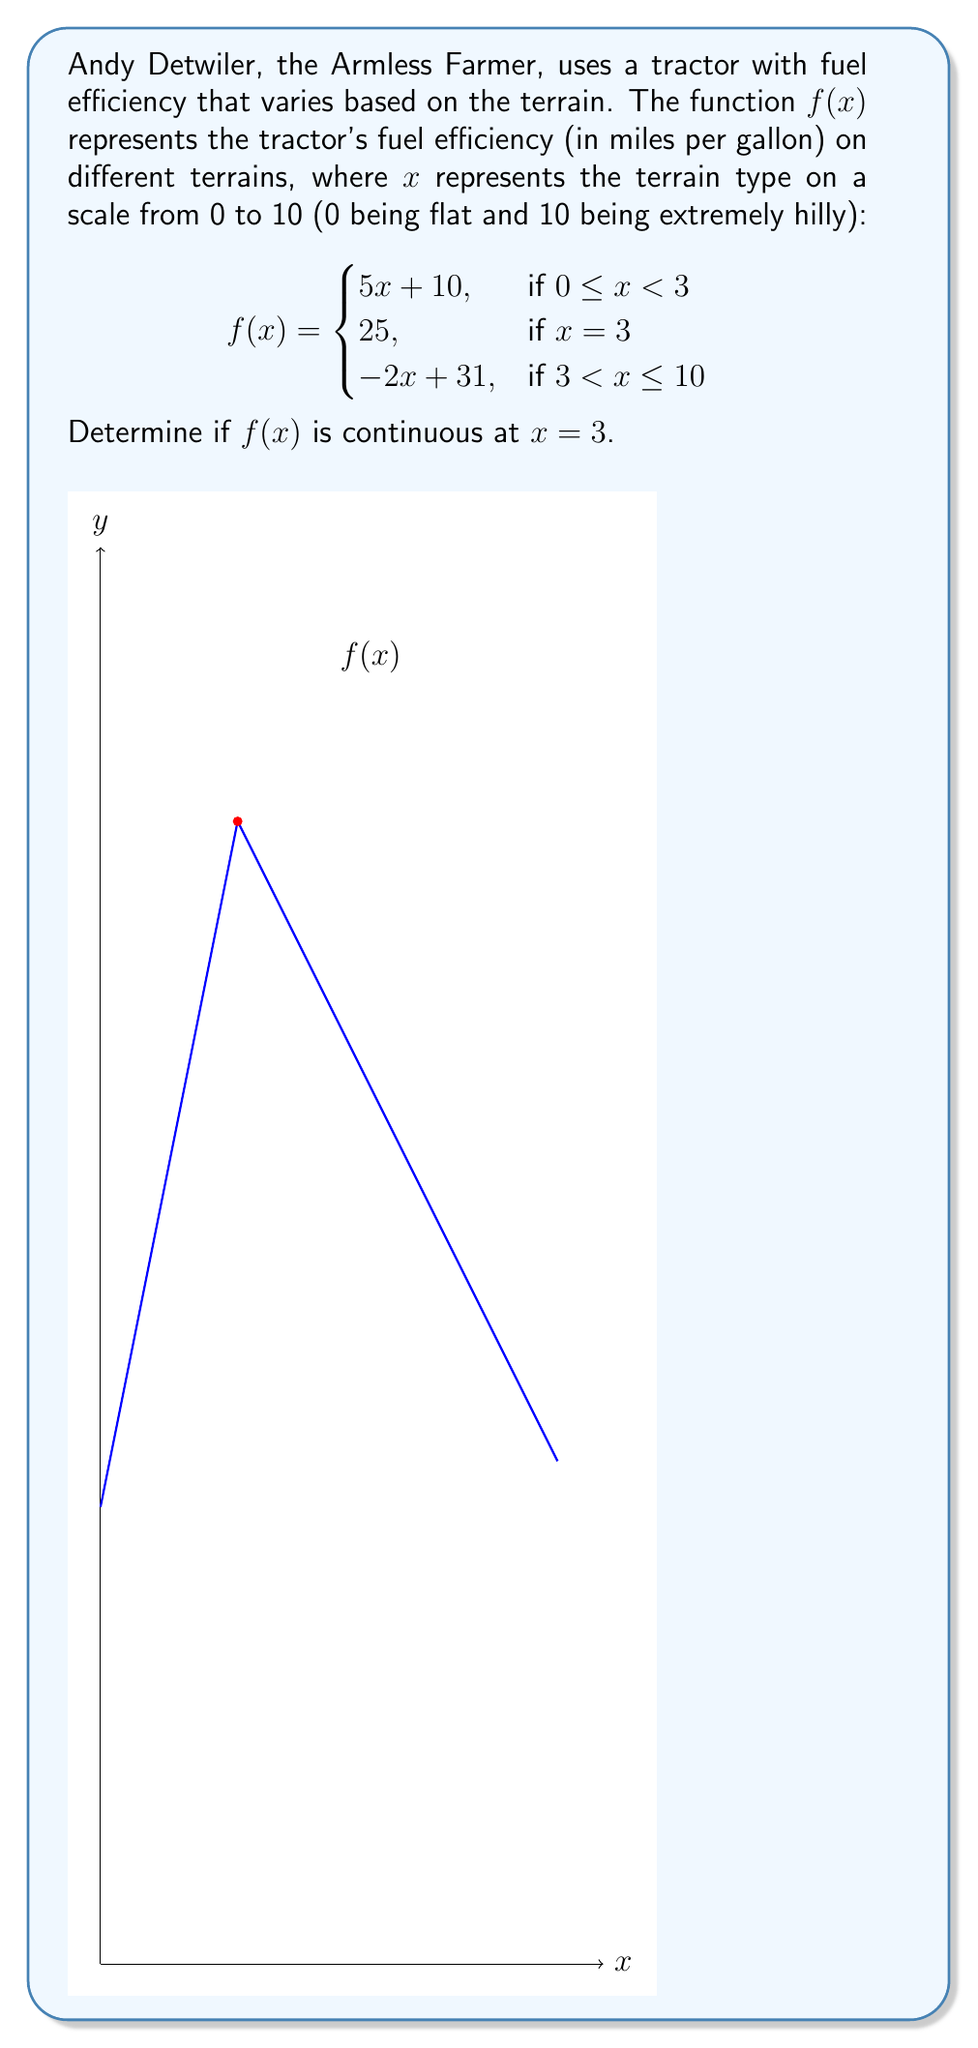Give your solution to this math problem. To determine if $f(x)$ is continuous at $x = 3$, we need to check three conditions:

1. $f(3)$ must exist.
2. $\lim_{x \to 3^-} f(x)$ must exist.
3. $\lim_{x \to 3^+} f(x)$ must exist.
4. All three values must be equal.

Step 1: Check if $f(3)$ exists
$f(3) = 25$ (given in the piecewise function)

Step 2: Calculate $\lim_{x \to 3^-} f(x)$
For $x < 3$, we use $f(x) = 5x + 10$
$\lim_{x \to 3^-} f(x) = \lim_{x \to 3^-} (5x + 10) = 5(3) + 10 = 25$

Step 3: Calculate $\lim_{x \to 3^+} f(x)$
For $x > 3$, we use $f(x) = -2x + 31$
$\lim_{x \to 3^+} f(x) = \lim_{x \to 3^+} (-2x + 31) = -2(3) + 31 = 25$

Step 4: Compare all values
$f(3) = 25$
$\lim_{x \to 3^-} f(x) = 25$
$\lim_{x \to 3^+} f(x) = 25$

All three values are equal to 25, satisfying all conditions for continuity.
Answer: $f(x)$ is continuous at $x = 3$. 